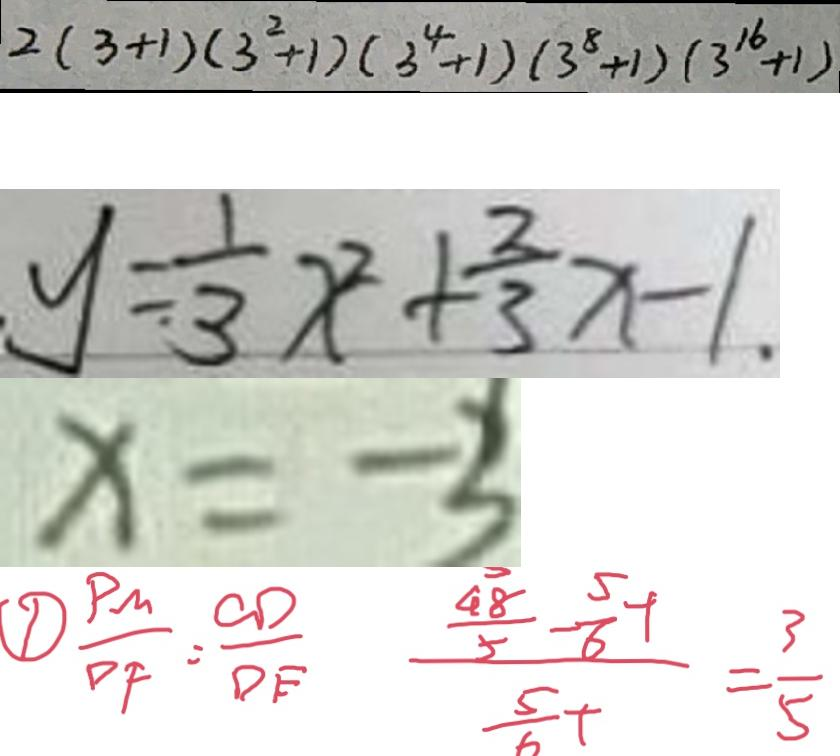Convert formula to latex. <formula><loc_0><loc_0><loc_500><loc_500>2 ( 3 + 1 ) ( 3 ^ { 2 } + 1 ) ( 3 ^ { 4 } + 1 ) ( 3 ^ { 8 } + 1 ) ( 3 ^ { 1 6 } + 1 ) 
 y = \frac { 1 } { 3 } x ^ { 2 } + \frac { 2 } { 3 } x - 1 . 
 x = - 3 
 \frac { P M } { D F } = \frac { C D } { D E } \frac { \frac { 4 8 } { 5 } - \frac { 5 } { 6 } t } { \frac { 5 } { 6 } t } = \frac { 3 } { 5 }</formula> 